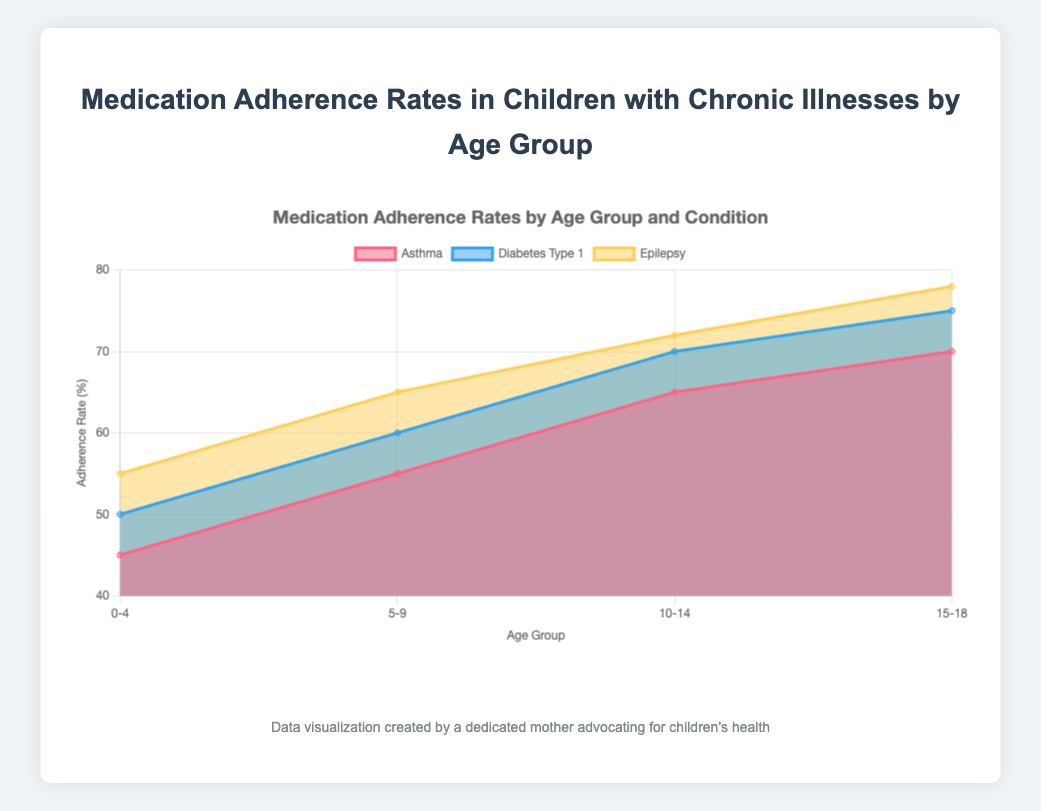Which age group has the highest adherence rate for Epilepsy? To find the answer, look at the adherence rates for Epilepsy across all age groups. The highest is found in the 15-18 age group.
Answer: 15-18 Which condition shows the lowest adherence rate in the 5-9 age group? Review the adherence rates for all conditions within the 5-9 age group. The lowest adherence rate is for Asthma.
Answer: Asthma What is the average adherence rate for all conditions in the 10-14 age group? Sum the adherence rates for all conditions in the 10-14 age group (65 for Asthma, 70 for Diabetes Type 1, 72 for Epilepsy) and divide by the number of conditions (3). The calculation is (65 + 70 + 72)/3 = 69.
Answer: 69 By how much does the adherence rate for Diabetes Type 1 increase from the 0-4 age group to the 15-18 age group? Subtract the adherence rate for Diabetes Type 1 in the 0-4 age group (50) from that in the 15-18 age group (75). The calculation is 75 - 50 = 25.
Answer: 25 Across all age groups, which condition shows the most consistent increase in adherence rates? Observe the trend lines for each condition across all age groups. Asthma, Diabetes Type 1, and Epilepsy all show consistent increases, but Epilepsy shows the most consistent, steady increase.
Answer: Epilepsy In the 0-4 age group, what is the total adherence rate sum for all conditions? Add the adherence rates for all conditions in the 0-4 age group (45 for Asthma, 50 for Diabetes Type 1, 55 for Epilepsy). The calculation is 45 + 50 + 55 = 150.
Answer: 150 Which age group exhibits the largest variance in adherence rates among the three conditions? Calculate the variance for each age group. The difference between highest and lowest values in each group is: 
- 0-4: 55 - 45 = 10
- 5-9: 65 - 55 = 10
- 10-14: 72 - 65 = 7
- 15-18: 78 - 70 = 8. 
The 0-4 and 5-9 age groups show the largest variance. Any would be a correct answer but 0-4 is often the typical first match.
Answer: 0-4 Is the trend in adherence rates for Asthma increasing or decreasing with age? Observe the line for Asthma across the age groups. It shows an increasing trend.
Answer: Increasing 